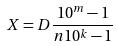Convert formula to latex. <formula><loc_0><loc_0><loc_500><loc_500>X = D \frac { 1 0 ^ { m } - 1 } { n 1 0 ^ { k } - 1 }</formula> 